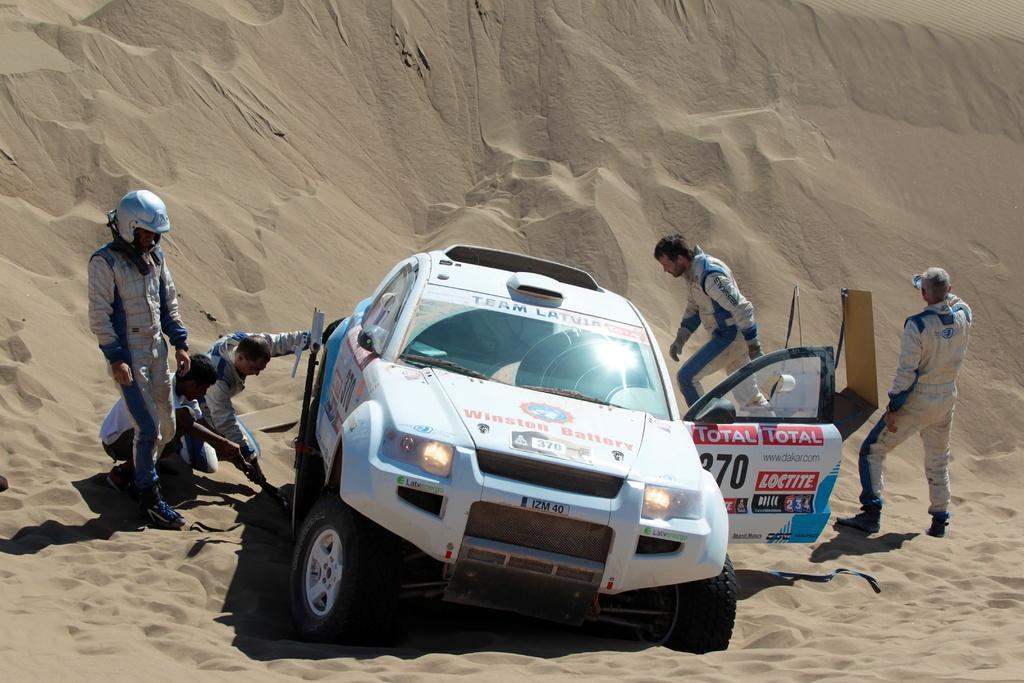How would you summarize this image in a sentence or two? In the center of the image we can see a car. In the background there are people and there is sand. 